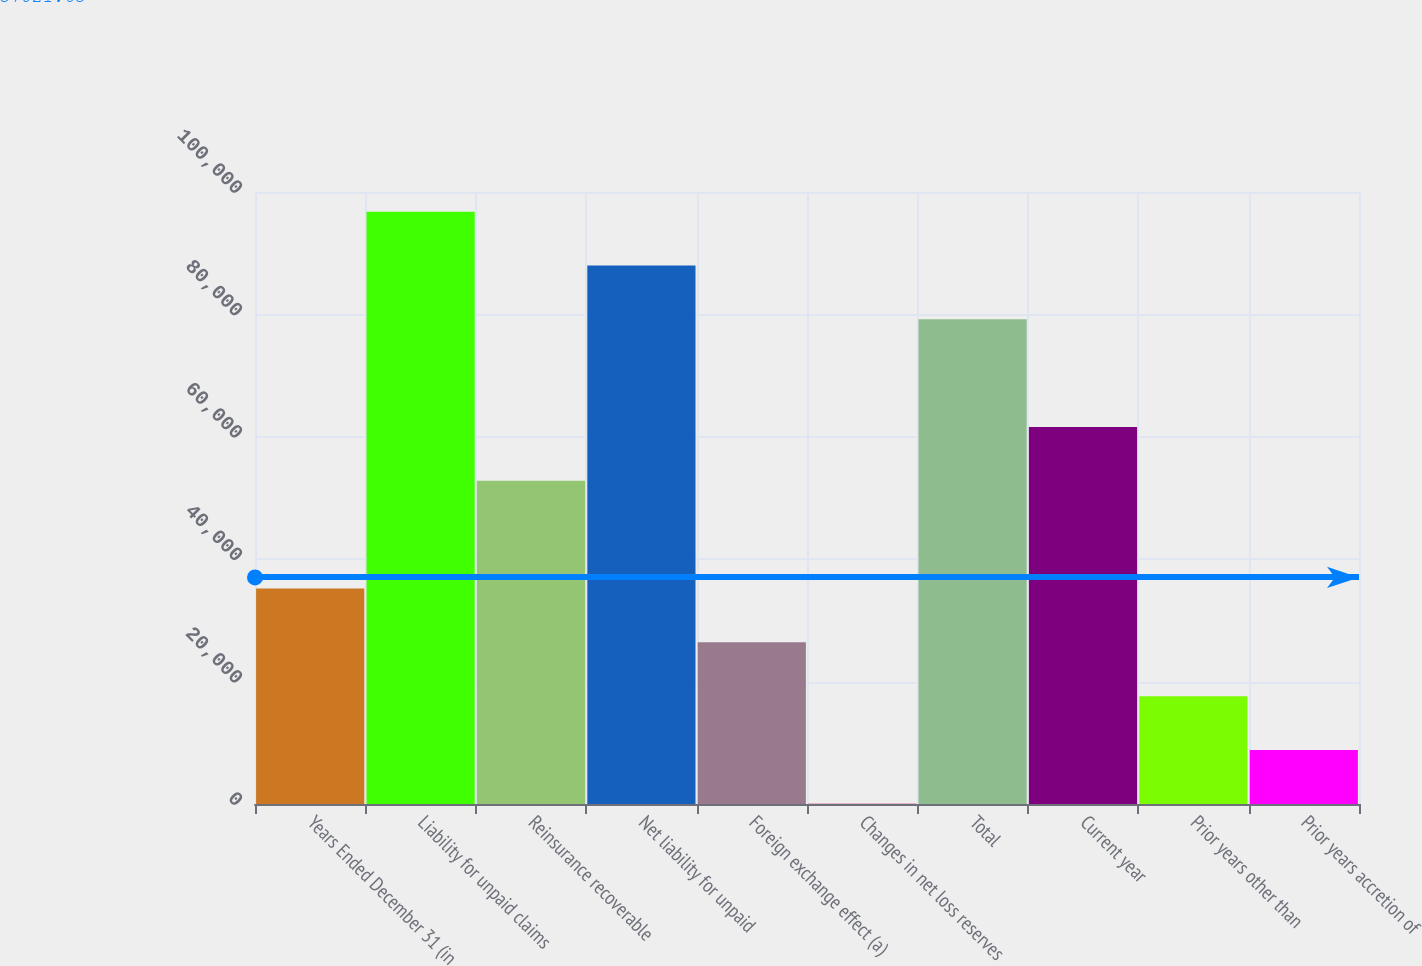Convert chart to OTSL. <chart><loc_0><loc_0><loc_500><loc_500><bar_chart><fcel>Years Ended December 31 (in<fcel>Liability for unpaid claims<fcel>Reinsurance recoverable<fcel>Net liability for unpaid<fcel>Foreign exchange effect (a)<fcel>Changes in net loss reserves<fcel>Total<fcel>Current year<fcel>Prior years other than<fcel>Prior years accretion of<nl><fcel>35209.6<fcel>96787.9<fcel>52803.4<fcel>87991<fcel>26412.7<fcel>22<fcel>79194.1<fcel>61600.3<fcel>17615.8<fcel>8818.9<nl></chart> 